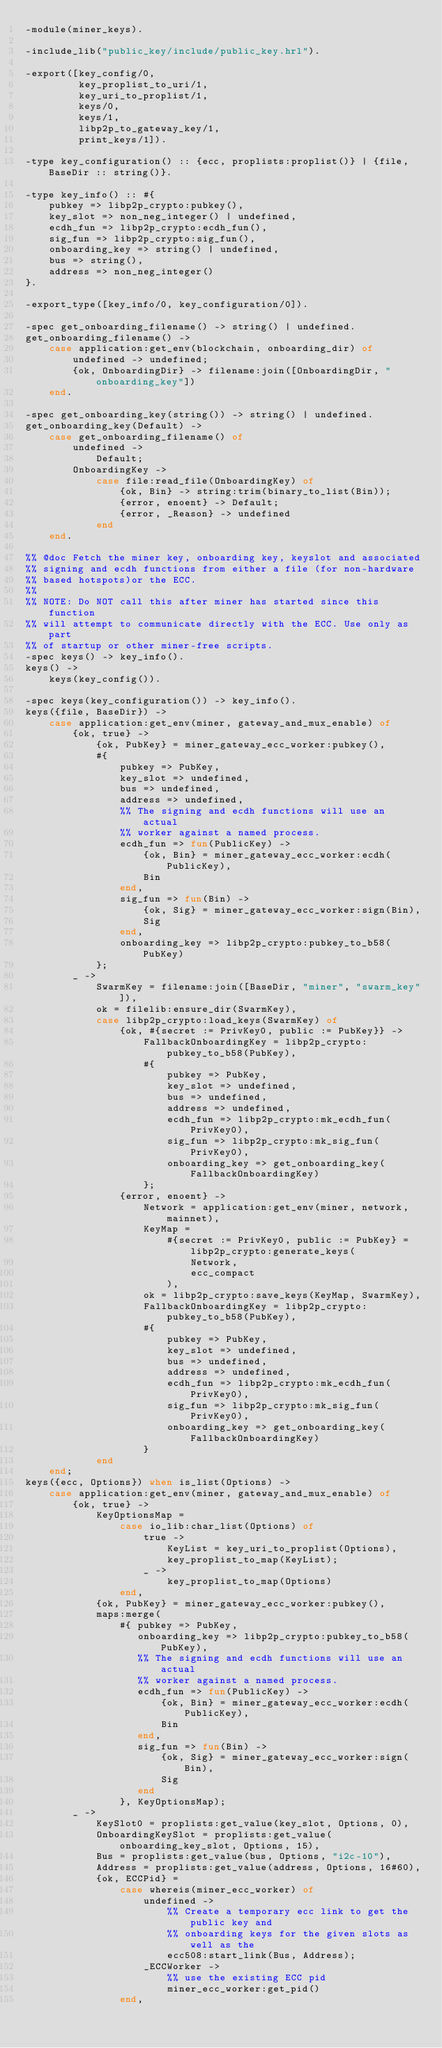<code> <loc_0><loc_0><loc_500><loc_500><_Erlang_>-module(miner_keys).

-include_lib("public_key/include/public_key.hrl").

-export([key_config/0,
         key_proplist_to_uri/1,
         key_uri_to_proplist/1,
         keys/0,
         keys/1,
         libp2p_to_gateway_key/1,
         print_keys/1]).

-type key_configuration() :: {ecc, proplists:proplist()} | {file, BaseDir :: string()}.

-type key_info() :: #{
    pubkey => libp2p_crypto:pubkey(),
    key_slot => non_neg_integer() | undefined,
    ecdh_fun => libp2p_crypto:ecdh_fun(),
    sig_fun => libp2p_crypto:sig_fun(),
    onboarding_key => string() | undefined,
    bus => string(),
    address => non_neg_integer()
}.

-export_type([key_info/0, key_configuration/0]).

-spec get_onboarding_filename() -> string() | undefined.
get_onboarding_filename() ->
    case application:get_env(blockchain, onboarding_dir) of
        undefined -> undefined;
        {ok, OnboardingDir} -> filename:join([OnboardingDir, "onboarding_key"])
    end.

-spec get_onboarding_key(string()) -> string() | undefined.
get_onboarding_key(Default) ->
    case get_onboarding_filename() of
        undefined ->
            Default;
        OnboardingKey ->
            case file:read_file(OnboardingKey) of
                {ok, Bin} -> string:trim(binary_to_list(Bin));
                {error, enoent} -> Default;
                {error, _Reason} -> undefined
            end
    end.

%% @doc Fetch the miner key, onboarding key, keyslot and associated
%% signing and ecdh functions from either a file (for non-hardware
%% based hotspots)or the ECC.
%%
%% NOTE: Do NOT call this after miner has started since this function
%% will attempt to communicate directly with the ECC. Use only as part
%% of startup or other miner-free scripts.
-spec keys() -> key_info().
keys() ->
    keys(key_config()).

-spec keys(key_configuration()) -> key_info().
keys({file, BaseDir}) ->
    case application:get_env(miner, gateway_and_mux_enable) of
        {ok, true} ->
            {ok, PubKey} = miner_gateway_ecc_worker:pubkey(),
            #{
                pubkey => PubKey,
                key_slot => undefined,
                bus => undefined,
                address => undefined,
                %% The signing and ecdh functions will use an actual
                %% worker against a named process.
                ecdh_fun => fun(PublicKey) ->
                    {ok, Bin} = miner_gateway_ecc_worker:ecdh(PublicKey),
                    Bin
                end,
                sig_fun => fun(Bin) ->
                    {ok, Sig} = miner_gateway_ecc_worker:sign(Bin),
                    Sig
                end,
                onboarding_key => libp2p_crypto:pubkey_to_b58(PubKey)
            };
        _ ->
            SwarmKey = filename:join([BaseDir, "miner", "swarm_key"]),
            ok = filelib:ensure_dir(SwarmKey),
            case libp2p_crypto:load_keys(SwarmKey) of
                {ok, #{secret := PrivKey0, public := PubKey}} ->
                    FallbackOnboardingKey = libp2p_crypto:pubkey_to_b58(PubKey),
                    #{
                        pubkey => PubKey,
                        key_slot => undefined,
                        bus => undefined,
                        address => undefined,
                        ecdh_fun => libp2p_crypto:mk_ecdh_fun(PrivKey0),
                        sig_fun => libp2p_crypto:mk_sig_fun(PrivKey0),
                        onboarding_key => get_onboarding_key(FallbackOnboardingKey)
                    };
                {error, enoent} ->
                    Network = application:get_env(miner, network, mainnet),
                    KeyMap =
                        #{secret := PrivKey0, public := PubKey} = libp2p_crypto:generate_keys(
                            Network,
                            ecc_compact
                        ),
                    ok = libp2p_crypto:save_keys(KeyMap, SwarmKey),
                    FallbackOnboardingKey = libp2p_crypto:pubkey_to_b58(PubKey),
                    #{
                        pubkey => PubKey,
                        key_slot => undefined,
                        bus => undefined,
                        address => undefined,
                        ecdh_fun => libp2p_crypto:mk_ecdh_fun(PrivKey0),
                        sig_fun => libp2p_crypto:mk_sig_fun(PrivKey0),
                        onboarding_key => get_onboarding_key(FallbackOnboardingKey)
                    }
            end
    end;
keys({ecc, Options}) when is_list(Options) ->
    case application:get_env(miner, gateway_and_mux_enable) of
        {ok, true} ->
            KeyOptionsMap =
                case io_lib:char_list(Options) of
                    true ->
                        KeyList = key_uri_to_proplist(Options),
                        key_proplist_to_map(KeyList);
                    _ ->
                        key_proplist_to_map(Options)
                end,
            {ok, PubKey} = miner_gateway_ecc_worker:pubkey(),
            maps:merge(
                #{ pubkey => PubKey,
                   onboarding_key => libp2p_crypto:pubkey_to_b58(PubKey),
                   %% The signing and ecdh functions will use an actual
                   %% worker against a named process.
                   ecdh_fun => fun(PublicKey) ->
                       {ok, Bin} = miner_gateway_ecc_worker:ecdh(PublicKey),
                       Bin
                   end,
                   sig_fun => fun(Bin) ->
                       {ok, Sig} = miner_gateway_ecc_worker:sign(Bin),
                       Sig
                   end
                }, KeyOptionsMap);
        _ ->
            KeySlot0 = proplists:get_value(key_slot, Options, 0),
            OnboardingKeySlot = proplists:get_value(onboarding_key_slot, Options, 15),
            Bus = proplists:get_value(bus, Options, "i2c-10"),
            Address = proplists:get_value(address, Options, 16#60),
            {ok, ECCPid} =
                case whereis(miner_ecc_worker) of
                    undefined ->
                        %% Create a temporary ecc link to get the public key and
                        %% onboarding keys for the given slots as well as the
                        ecc508:start_link(Bus, Address);
                    _ECCWorker ->
                        %% use the existing ECC pid
                        miner_ecc_worker:get_pid()
                end,</code> 